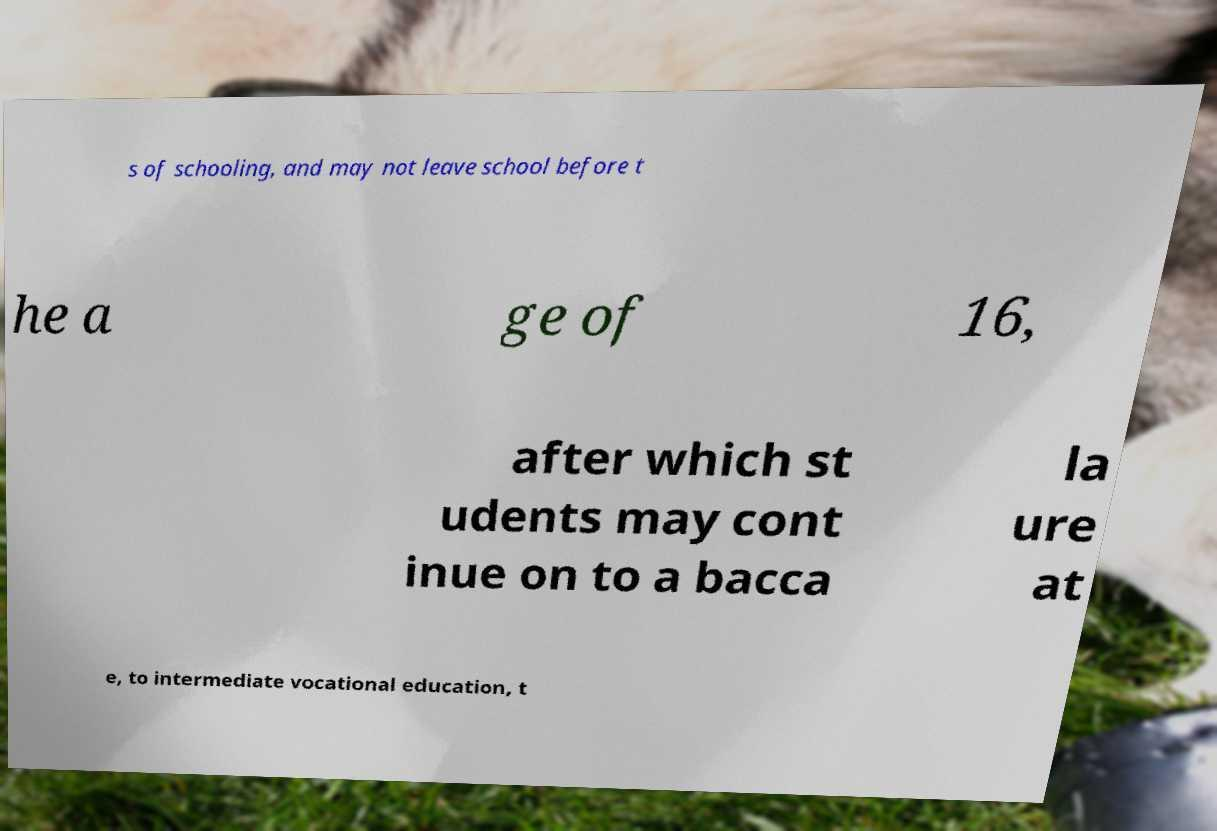Could you assist in decoding the text presented in this image and type it out clearly? s of schooling, and may not leave school before t he a ge of 16, after which st udents may cont inue on to a bacca la ure at e, to intermediate vocational education, t 